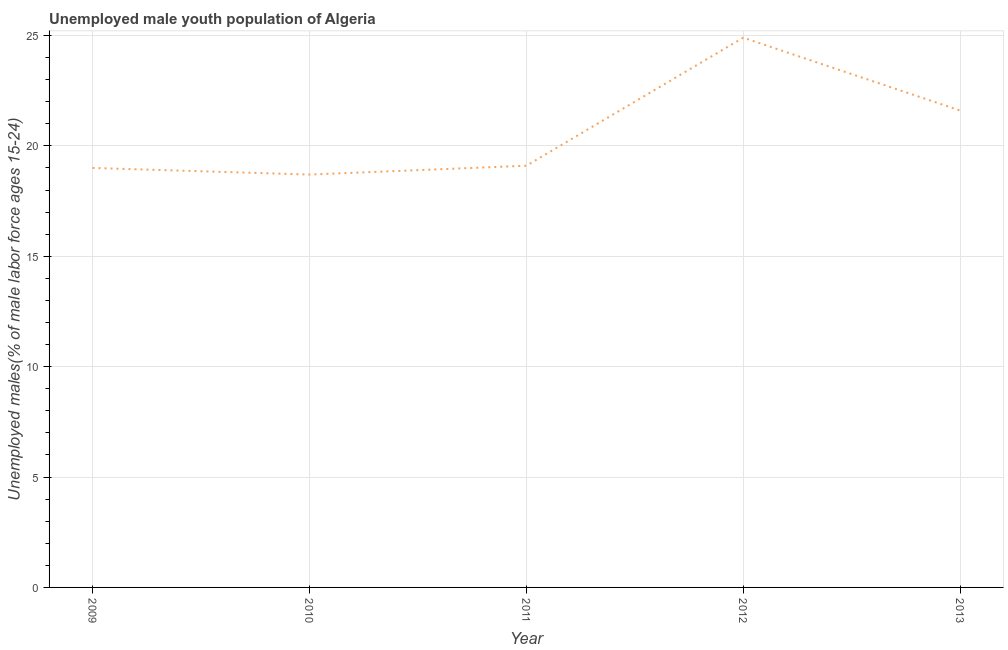What is the unemployed male youth in 2011?
Make the answer very short. 19.1. Across all years, what is the maximum unemployed male youth?
Your response must be concise. 24.9. Across all years, what is the minimum unemployed male youth?
Offer a very short reply. 18.7. In which year was the unemployed male youth maximum?
Your response must be concise. 2012. What is the sum of the unemployed male youth?
Ensure brevity in your answer.  103.3. What is the difference between the unemployed male youth in 2011 and 2013?
Make the answer very short. -2.5. What is the average unemployed male youth per year?
Your answer should be compact. 20.66. What is the median unemployed male youth?
Your answer should be very brief. 19.1. What is the ratio of the unemployed male youth in 2009 to that in 2013?
Your response must be concise. 0.88. What is the difference between the highest and the second highest unemployed male youth?
Your answer should be compact. 3.3. What is the difference between the highest and the lowest unemployed male youth?
Provide a succinct answer. 6.2. How many years are there in the graph?
Your answer should be very brief. 5. What is the difference between two consecutive major ticks on the Y-axis?
Keep it short and to the point. 5. Are the values on the major ticks of Y-axis written in scientific E-notation?
Give a very brief answer. No. Does the graph contain any zero values?
Your answer should be compact. No. What is the title of the graph?
Your answer should be compact. Unemployed male youth population of Algeria. What is the label or title of the X-axis?
Give a very brief answer. Year. What is the label or title of the Y-axis?
Provide a succinct answer. Unemployed males(% of male labor force ages 15-24). What is the Unemployed males(% of male labor force ages 15-24) of 2010?
Offer a very short reply. 18.7. What is the Unemployed males(% of male labor force ages 15-24) of 2011?
Give a very brief answer. 19.1. What is the Unemployed males(% of male labor force ages 15-24) in 2012?
Provide a short and direct response. 24.9. What is the Unemployed males(% of male labor force ages 15-24) in 2013?
Make the answer very short. 21.6. What is the difference between the Unemployed males(% of male labor force ages 15-24) in 2009 and 2010?
Your response must be concise. 0.3. What is the difference between the Unemployed males(% of male labor force ages 15-24) in 2009 and 2011?
Provide a succinct answer. -0.1. What is the ratio of the Unemployed males(% of male labor force ages 15-24) in 2009 to that in 2010?
Give a very brief answer. 1.02. What is the ratio of the Unemployed males(% of male labor force ages 15-24) in 2009 to that in 2012?
Ensure brevity in your answer.  0.76. What is the ratio of the Unemployed males(% of male labor force ages 15-24) in 2009 to that in 2013?
Keep it short and to the point. 0.88. What is the ratio of the Unemployed males(% of male labor force ages 15-24) in 2010 to that in 2012?
Provide a succinct answer. 0.75. What is the ratio of the Unemployed males(% of male labor force ages 15-24) in 2010 to that in 2013?
Your answer should be very brief. 0.87. What is the ratio of the Unemployed males(% of male labor force ages 15-24) in 2011 to that in 2012?
Make the answer very short. 0.77. What is the ratio of the Unemployed males(% of male labor force ages 15-24) in 2011 to that in 2013?
Provide a short and direct response. 0.88. What is the ratio of the Unemployed males(% of male labor force ages 15-24) in 2012 to that in 2013?
Your answer should be compact. 1.15. 